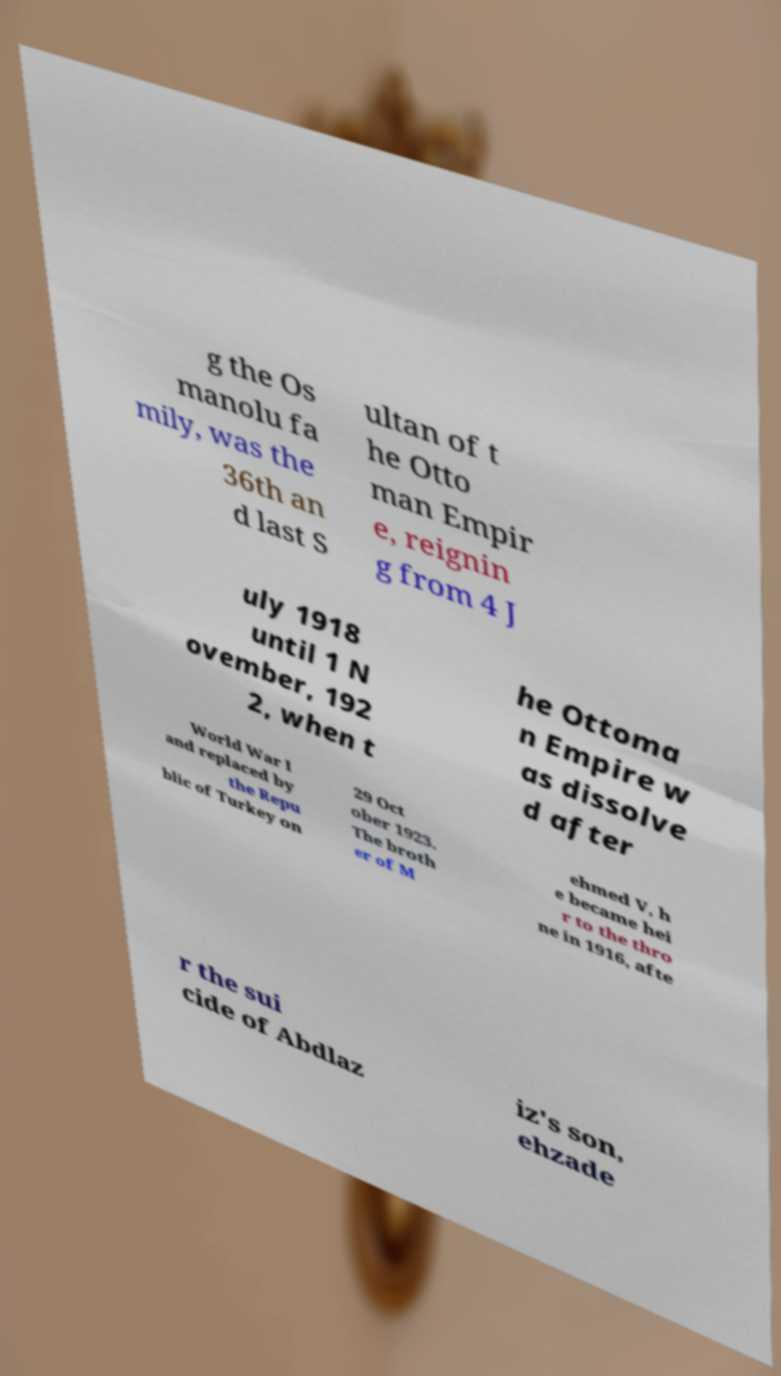Could you extract and type out the text from this image? g the Os manolu fa mily, was the 36th an d last S ultan of t he Otto man Empir e, reignin g from 4 J uly 1918 until 1 N ovember, 192 2, when t he Ottoma n Empire w as dissolve d after World War I and replaced by the Repu blic of Turkey on 29 Oct ober 1923. The broth er of M ehmed V, h e became hei r to the thro ne in 1916, afte r the sui cide of Abdlaz iz's son, ehzade 